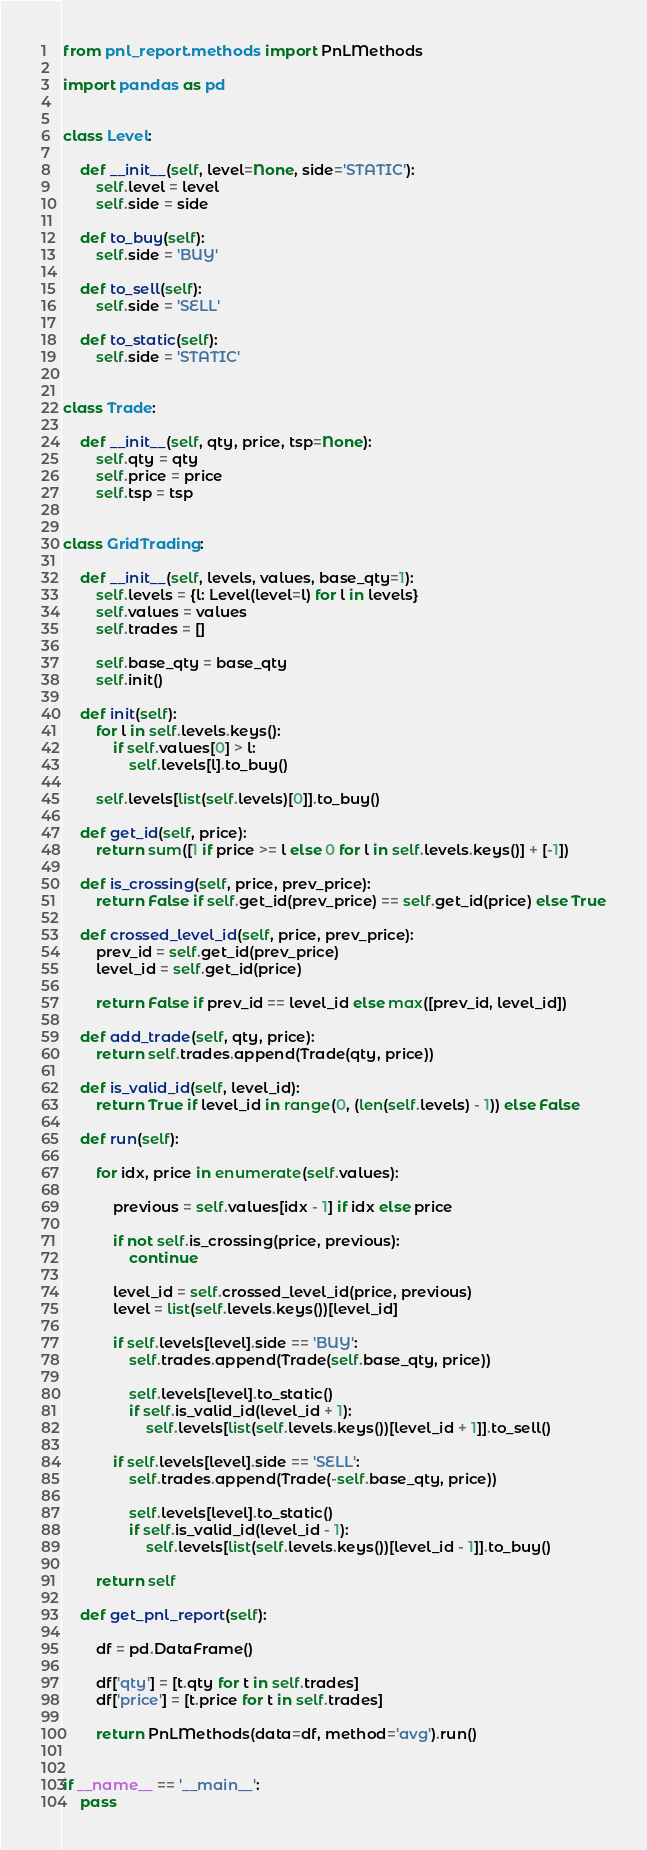<code> <loc_0><loc_0><loc_500><loc_500><_Python_>from pnl_report.methods import PnLMethods

import pandas as pd


class Level:

    def __init__(self, level=None, side='STATIC'):
        self.level = level
        self.side = side

    def to_buy(self):
        self.side = 'BUY'

    def to_sell(self):
        self.side = 'SELL'

    def to_static(self):
        self.side = 'STATIC'


class Trade:

    def __init__(self, qty, price, tsp=None):
        self.qty = qty
        self.price = price
        self.tsp = tsp


class GridTrading:

    def __init__(self, levels, values, base_qty=1):
        self.levels = {l: Level(level=l) for l in levels}
        self.values = values
        self.trades = []

        self.base_qty = base_qty
        self.init()

    def init(self):
        for l in self.levels.keys():
            if self.values[0] > l:
                self.levels[l].to_buy()

        self.levels[list(self.levels)[0]].to_buy()

    def get_id(self, price):
        return sum([1 if price >= l else 0 for l in self.levels.keys()] + [-1])

    def is_crossing(self, price, prev_price):
        return False if self.get_id(prev_price) == self.get_id(price) else True

    def crossed_level_id(self, price, prev_price):
        prev_id = self.get_id(prev_price)
        level_id = self.get_id(price)

        return False if prev_id == level_id else max([prev_id, level_id])

    def add_trade(self, qty, price):
        return self.trades.append(Trade(qty, price))

    def is_valid_id(self, level_id):
        return True if level_id in range(0, (len(self.levels) - 1)) else False

    def run(self):

        for idx, price in enumerate(self.values):

            previous = self.values[idx - 1] if idx else price

            if not self.is_crossing(price, previous):
                continue

            level_id = self.crossed_level_id(price, previous)
            level = list(self.levels.keys())[level_id]

            if self.levels[level].side == 'BUY':
                self.trades.append(Trade(self.base_qty, price))

                self.levels[level].to_static()
                if self.is_valid_id(level_id + 1):
                    self.levels[list(self.levels.keys())[level_id + 1]].to_sell()

            if self.levels[level].side == 'SELL':
                self.trades.append(Trade(-self.base_qty, price))

                self.levels[level].to_static()
                if self.is_valid_id(level_id - 1):
                    self.levels[list(self.levels.keys())[level_id - 1]].to_buy()

        return self

    def get_pnl_report(self):

        df = pd.DataFrame()

        df['qty'] = [t.qty for t in self.trades]
        df['price'] = [t.price for t in self.trades]

        return PnLMethods(data=df, method='avg').run()


if __name__ == '__main__':
    pass</code> 